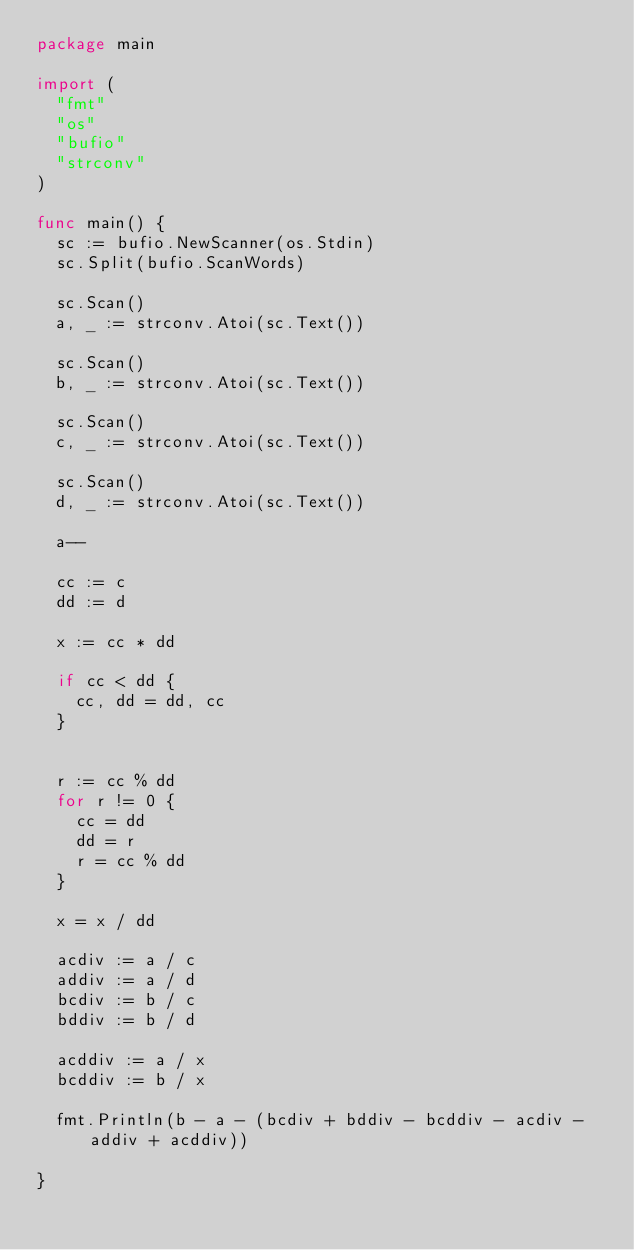<code> <loc_0><loc_0><loc_500><loc_500><_Go_>package main

import (
  "fmt"
  "os"
  "bufio"
  "strconv"
)

func main() {
  sc := bufio.NewScanner(os.Stdin)
  sc.Split(bufio.ScanWords)

  sc.Scan()
  a, _ := strconv.Atoi(sc.Text())

  sc.Scan()
  b, _ := strconv.Atoi(sc.Text())

  sc.Scan()
  c, _ := strconv.Atoi(sc.Text())

  sc.Scan()
  d, _ := strconv.Atoi(sc.Text())

  a--

  cc := c
  dd := d

  x := cc * dd

  if cc < dd {
    cc, dd = dd, cc
  }


  r := cc % dd
  for r != 0 {
    cc = dd
    dd = r
    r = cc % dd
  }

  x = x / dd

  acdiv := a / c
  addiv := a / d
  bcdiv := b / c
  bddiv := b / d

  acddiv := a / x
  bcddiv := b / x

  fmt.Println(b - a - (bcdiv + bddiv - bcddiv - acdiv - addiv + acddiv))

}

</code> 